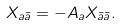<formula> <loc_0><loc_0><loc_500><loc_500>X _ { a \bar { a } } = - A _ { a } X _ { \bar { a } \bar { a } } .</formula> 